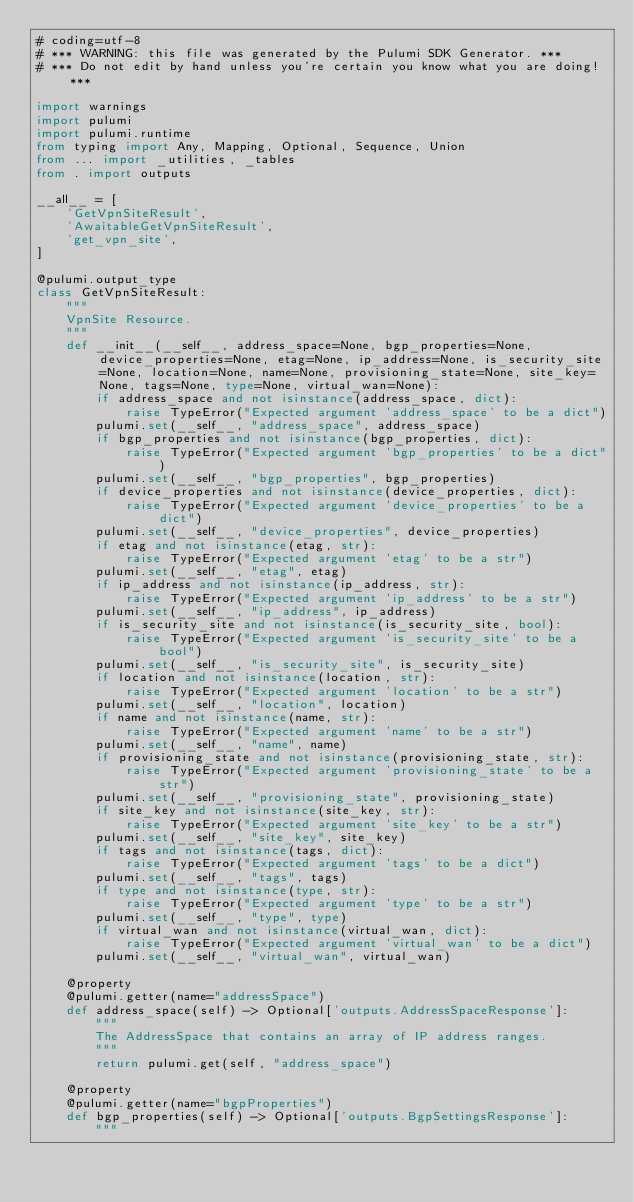<code> <loc_0><loc_0><loc_500><loc_500><_Python_># coding=utf-8
# *** WARNING: this file was generated by the Pulumi SDK Generator. ***
# *** Do not edit by hand unless you're certain you know what you are doing! ***

import warnings
import pulumi
import pulumi.runtime
from typing import Any, Mapping, Optional, Sequence, Union
from ... import _utilities, _tables
from . import outputs

__all__ = [
    'GetVpnSiteResult',
    'AwaitableGetVpnSiteResult',
    'get_vpn_site',
]

@pulumi.output_type
class GetVpnSiteResult:
    """
    VpnSite Resource.
    """
    def __init__(__self__, address_space=None, bgp_properties=None, device_properties=None, etag=None, ip_address=None, is_security_site=None, location=None, name=None, provisioning_state=None, site_key=None, tags=None, type=None, virtual_wan=None):
        if address_space and not isinstance(address_space, dict):
            raise TypeError("Expected argument 'address_space' to be a dict")
        pulumi.set(__self__, "address_space", address_space)
        if bgp_properties and not isinstance(bgp_properties, dict):
            raise TypeError("Expected argument 'bgp_properties' to be a dict")
        pulumi.set(__self__, "bgp_properties", bgp_properties)
        if device_properties and not isinstance(device_properties, dict):
            raise TypeError("Expected argument 'device_properties' to be a dict")
        pulumi.set(__self__, "device_properties", device_properties)
        if etag and not isinstance(etag, str):
            raise TypeError("Expected argument 'etag' to be a str")
        pulumi.set(__self__, "etag", etag)
        if ip_address and not isinstance(ip_address, str):
            raise TypeError("Expected argument 'ip_address' to be a str")
        pulumi.set(__self__, "ip_address", ip_address)
        if is_security_site and not isinstance(is_security_site, bool):
            raise TypeError("Expected argument 'is_security_site' to be a bool")
        pulumi.set(__self__, "is_security_site", is_security_site)
        if location and not isinstance(location, str):
            raise TypeError("Expected argument 'location' to be a str")
        pulumi.set(__self__, "location", location)
        if name and not isinstance(name, str):
            raise TypeError("Expected argument 'name' to be a str")
        pulumi.set(__self__, "name", name)
        if provisioning_state and not isinstance(provisioning_state, str):
            raise TypeError("Expected argument 'provisioning_state' to be a str")
        pulumi.set(__self__, "provisioning_state", provisioning_state)
        if site_key and not isinstance(site_key, str):
            raise TypeError("Expected argument 'site_key' to be a str")
        pulumi.set(__self__, "site_key", site_key)
        if tags and not isinstance(tags, dict):
            raise TypeError("Expected argument 'tags' to be a dict")
        pulumi.set(__self__, "tags", tags)
        if type and not isinstance(type, str):
            raise TypeError("Expected argument 'type' to be a str")
        pulumi.set(__self__, "type", type)
        if virtual_wan and not isinstance(virtual_wan, dict):
            raise TypeError("Expected argument 'virtual_wan' to be a dict")
        pulumi.set(__self__, "virtual_wan", virtual_wan)

    @property
    @pulumi.getter(name="addressSpace")
    def address_space(self) -> Optional['outputs.AddressSpaceResponse']:
        """
        The AddressSpace that contains an array of IP address ranges.
        """
        return pulumi.get(self, "address_space")

    @property
    @pulumi.getter(name="bgpProperties")
    def bgp_properties(self) -> Optional['outputs.BgpSettingsResponse']:
        """</code> 